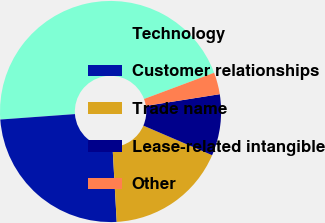<chart> <loc_0><loc_0><loc_500><loc_500><pie_chart><fcel>Technology<fcel>Customer relationships<fcel>Trade name<fcel>Lease-related intangible<fcel>Other<nl><fcel>45.46%<fcel>24.73%<fcel>17.65%<fcel>8.97%<fcel>3.19%<nl></chart> 